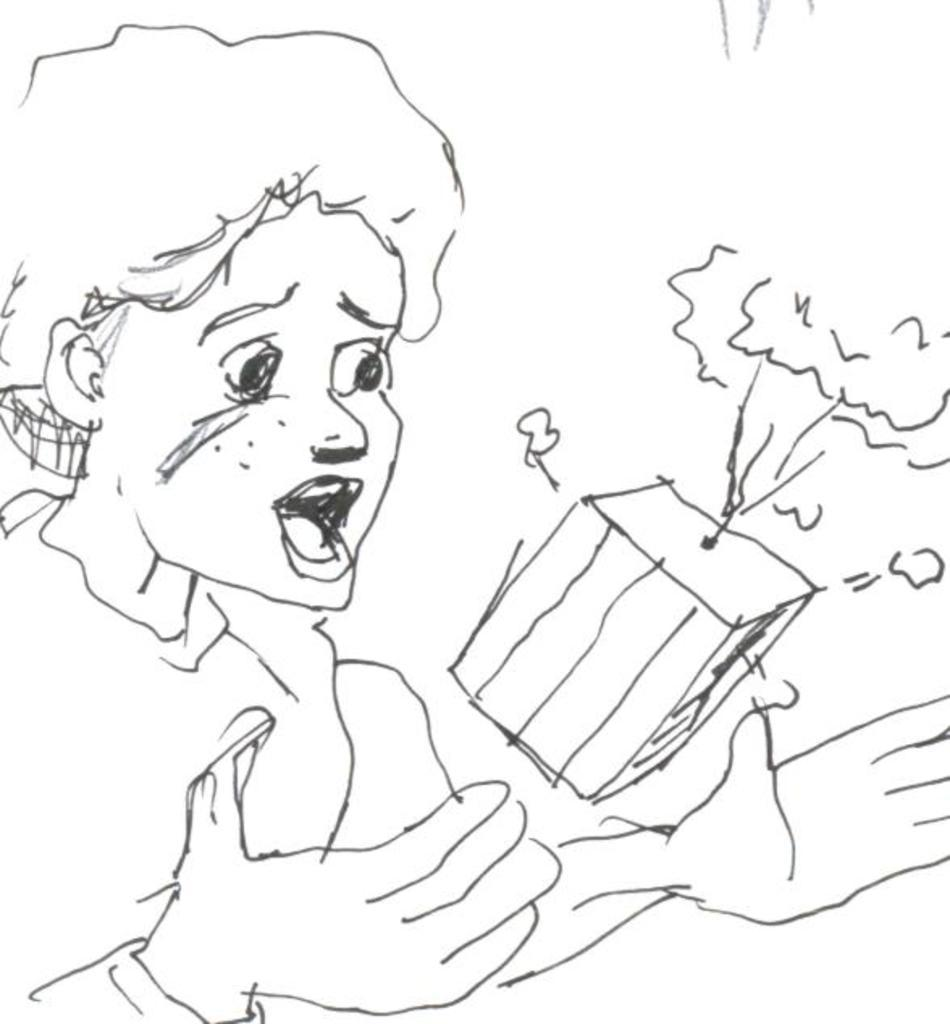What is depicted in the image? There is a sketch of a person in the image. What other object can be seen in the image? There is a box in the image. What is the color of the surface in the image? The surface in the image is white-colored. How is the person in the image using a baseball bat? There is no baseball bat present in the image; it only features a sketch of a person and a box. 